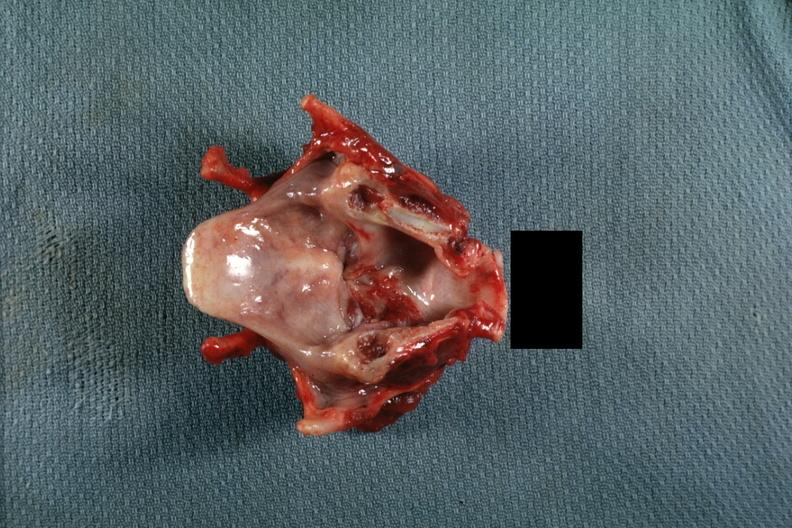s carcinoma present?
Answer the question using a single word or phrase. Yes 